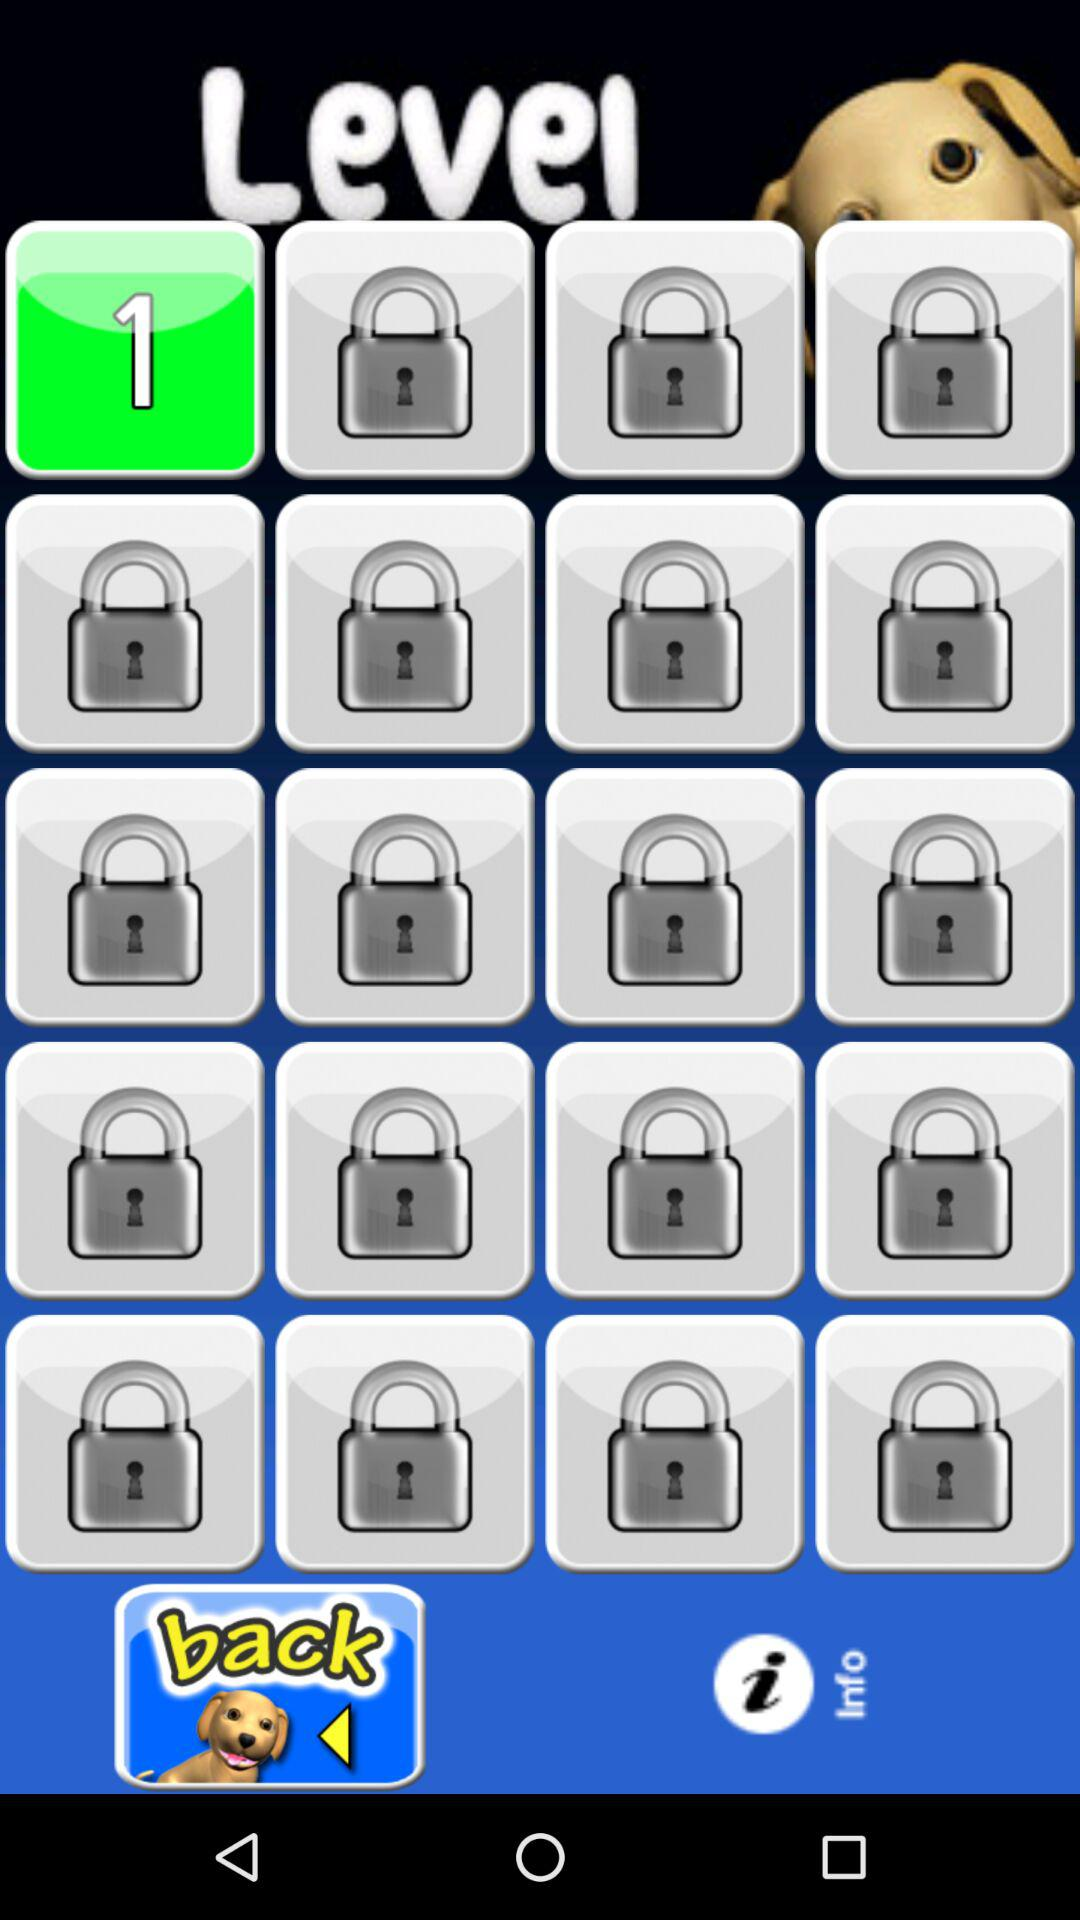On which level is the person? The person is on the first level. 